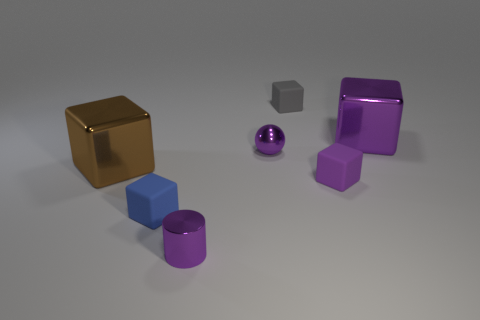What shape is the purple metal thing that is the same size as the purple shiny cylinder?
Provide a succinct answer. Sphere. What is the shape of the small shiny thing that is behind the brown block that is left of the tiny thing on the right side of the small gray rubber block?
Make the answer very short. Sphere. How many other objects are the same material as the small ball?
Keep it short and to the point. 3. Are there the same number of purple cylinders behind the blue matte block and tiny shiny cylinders?
Your response must be concise. No. Does the cylinder have the same size as the gray block that is to the right of the big brown thing?
Provide a succinct answer. Yes. What is the shape of the big shiny thing in front of the big purple metallic thing?
Your response must be concise. Cube. Are there any other things that are the same shape as the brown object?
Provide a succinct answer. Yes. Is there a tiny blue rubber cube?
Make the answer very short. Yes. There is a shiny thing that is to the right of the small purple cube; is its size the same as the shiny cube to the left of the gray cube?
Make the answer very short. Yes. There is a purple thing that is both left of the gray matte block and behind the small purple matte thing; what is it made of?
Make the answer very short. Metal. 